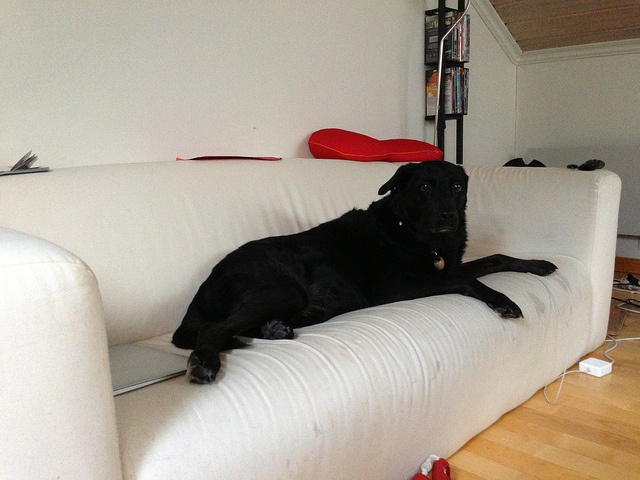Describe the objects in this image and their specific colors. I can see couch in darkgray and lightgray tones, dog in darkgray, black, gray, and lightgray tones, laptop in darkgray and gray tones, book in darkgray, black, and gray tones, and book in darkgray, gray, black, and maroon tones in this image. 